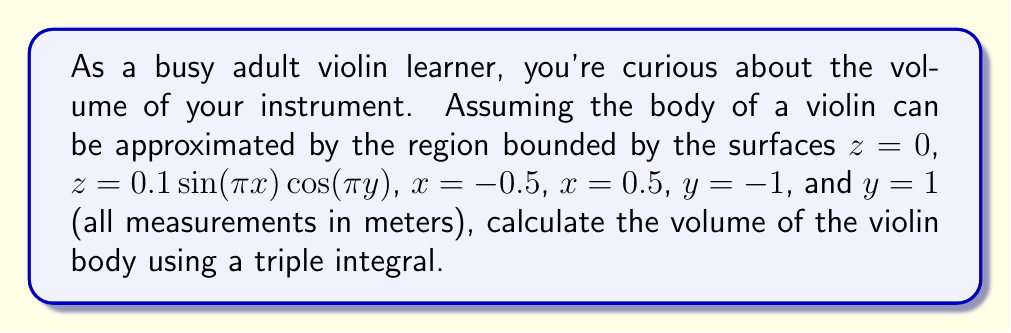Teach me how to tackle this problem. To calculate the volume using a triple integral, we need to integrate the constant function 1 over the given region. The bounds of integration are given by the surfaces that define the violin's shape.

1. Set up the triple integral:
   $$V = \iiint_V 1 \,dV = \int_{-1}^1 \int_{-0.5}^{0.5} \int_0^{0.1 \sin(\pi x) \cos(\pi y)} 1 \,dz\,dx\,dy$$

2. Evaluate the innermost integral with respect to z:
   $$V = \int_{-1}^1 \int_{-0.5}^{0.5} [z]_0^{0.1 \sin(\pi x) \cos(\pi y)} \,dx\,dy$$
   $$V = \int_{-1}^1 \int_{-0.5}^{0.5} 0.1 \sin(\pi x) \cos(\pi y) \,dx\,dy$$

3. Evaluate the integral with respect to x:
   $$V = \int_{-1}^1 \left[-\frac{0.1}{\pi} \cos(\pi x) \cos(\pi y)\right]_{-0.5}^{0.5} \,dy$$
   $$V = \int_{-1}^1 \frac{0.2}{\pi} \cos(\pi y) \,dy$$

4. Finally, evaluate the integral with respect to y:
   $$V = \left[\frac{0.2}{\pi^2} \sin(\pi y)\right]_{-1}^1$$
   $$V = \frac{0.4}{\pi^2}$$

5. Convert the result to cubic meters:
   $$V = \frac{0.4}{\pi^2} \approx 0.0405 \text{ m}^3$$
Answer: The volume of the violin body is approximately 0.0405 cubic meters. 